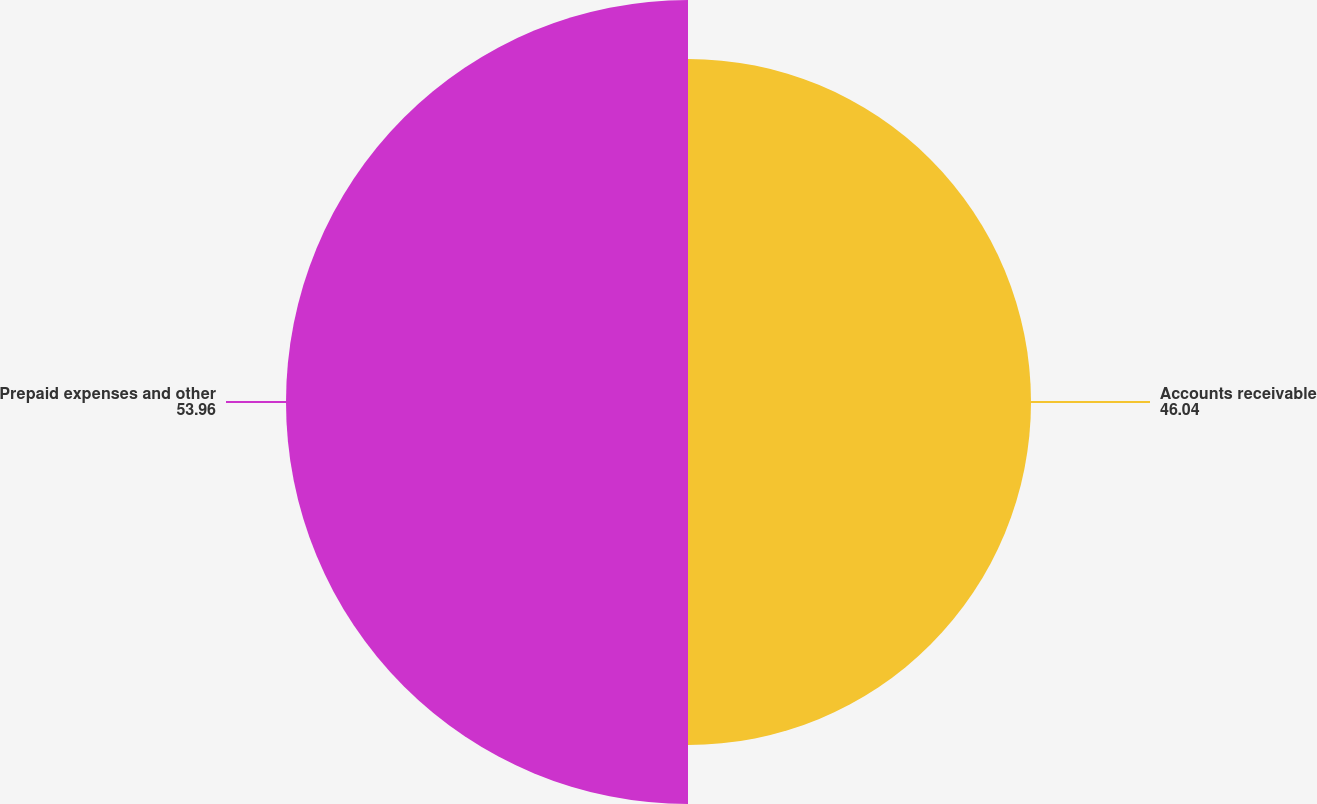Convert chart. <chart><loc_0><loc_0><loc_500><loc_500><pie_chart><fcel>Accounts receivable<fcel>Prepaid expenses and other<nl><fcel>46.04%<fcel>53.96%<nl></chart> 